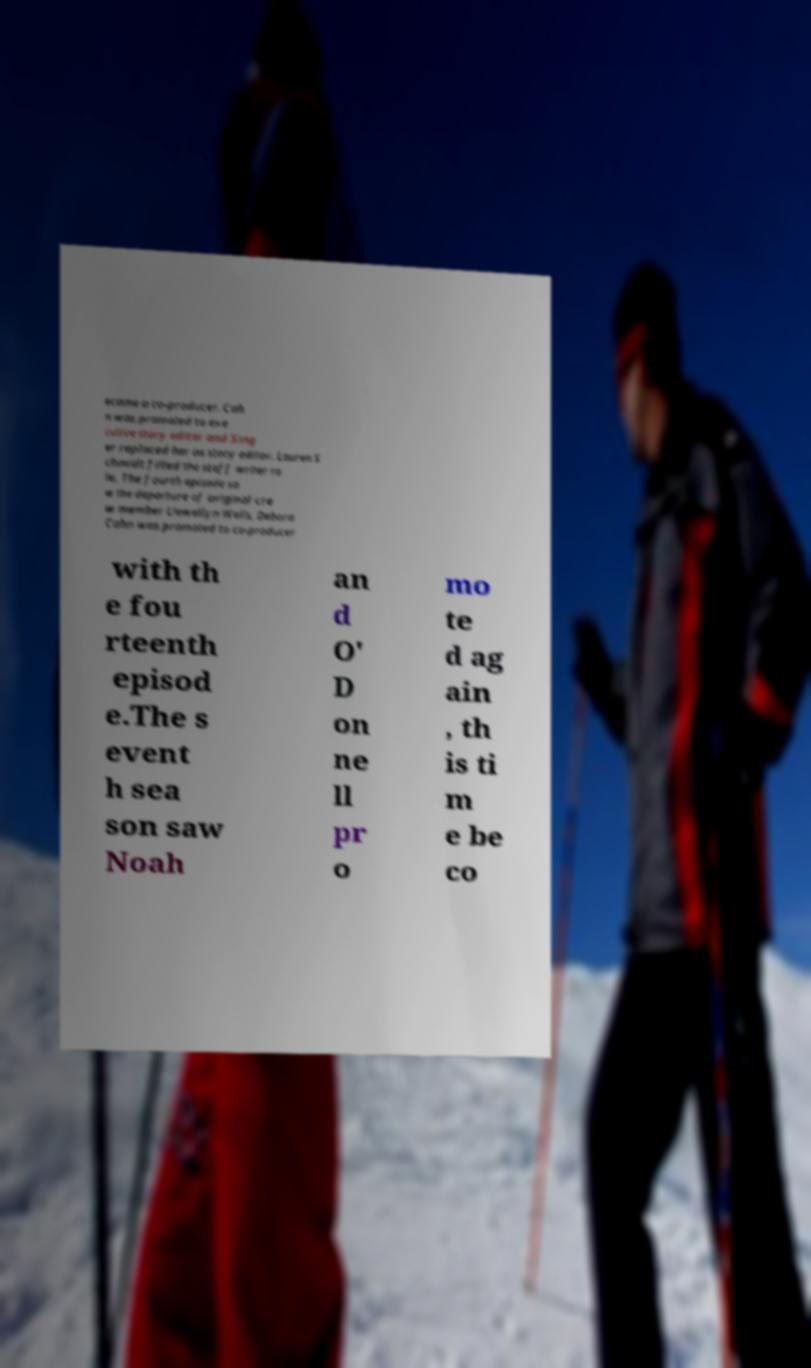Can you read and provide the text displayed in the image?This photo seems to have some interesting text. Can you extract and type it out for me? ecame a co-producer. Cah n was promoted to exe cutive story editor and Sing er replaced her as story editor. Lauren S chmidt filled the staff writer ro le. The fourth episode sa w the departure of original cre w member Llewellyn Wells. Debora Cahn was promoted to co-producer with th e fou rteenth episod e.The s event h sea son saw Noah an d O' D on ne ll pr o mo te d ag ain , th is ti m e be co 